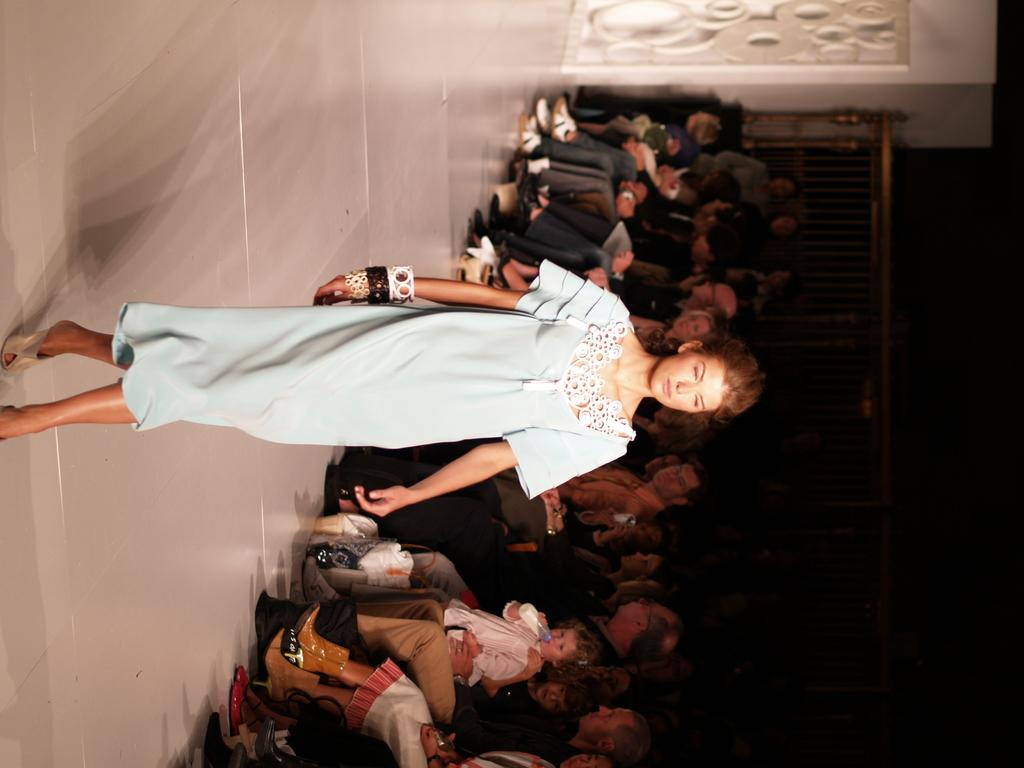Who is the main subject in the image? There is a girl in the center of the image. What are the people in the image doing? The people in the image are sitting on chairs. Can you describe any architectural features in the image? Yes, there appears to be a door in the image. What is located on the right side of the image? There is a metal gate on the right side of the image. What type of toothbrush is the girl using in the image? There is no toothbrush present in the image. How does the girl's digestion affect the people sitting on chairs in the image? There is no mention of digestion in the image, and it does not affect the people sitting on chairs. 